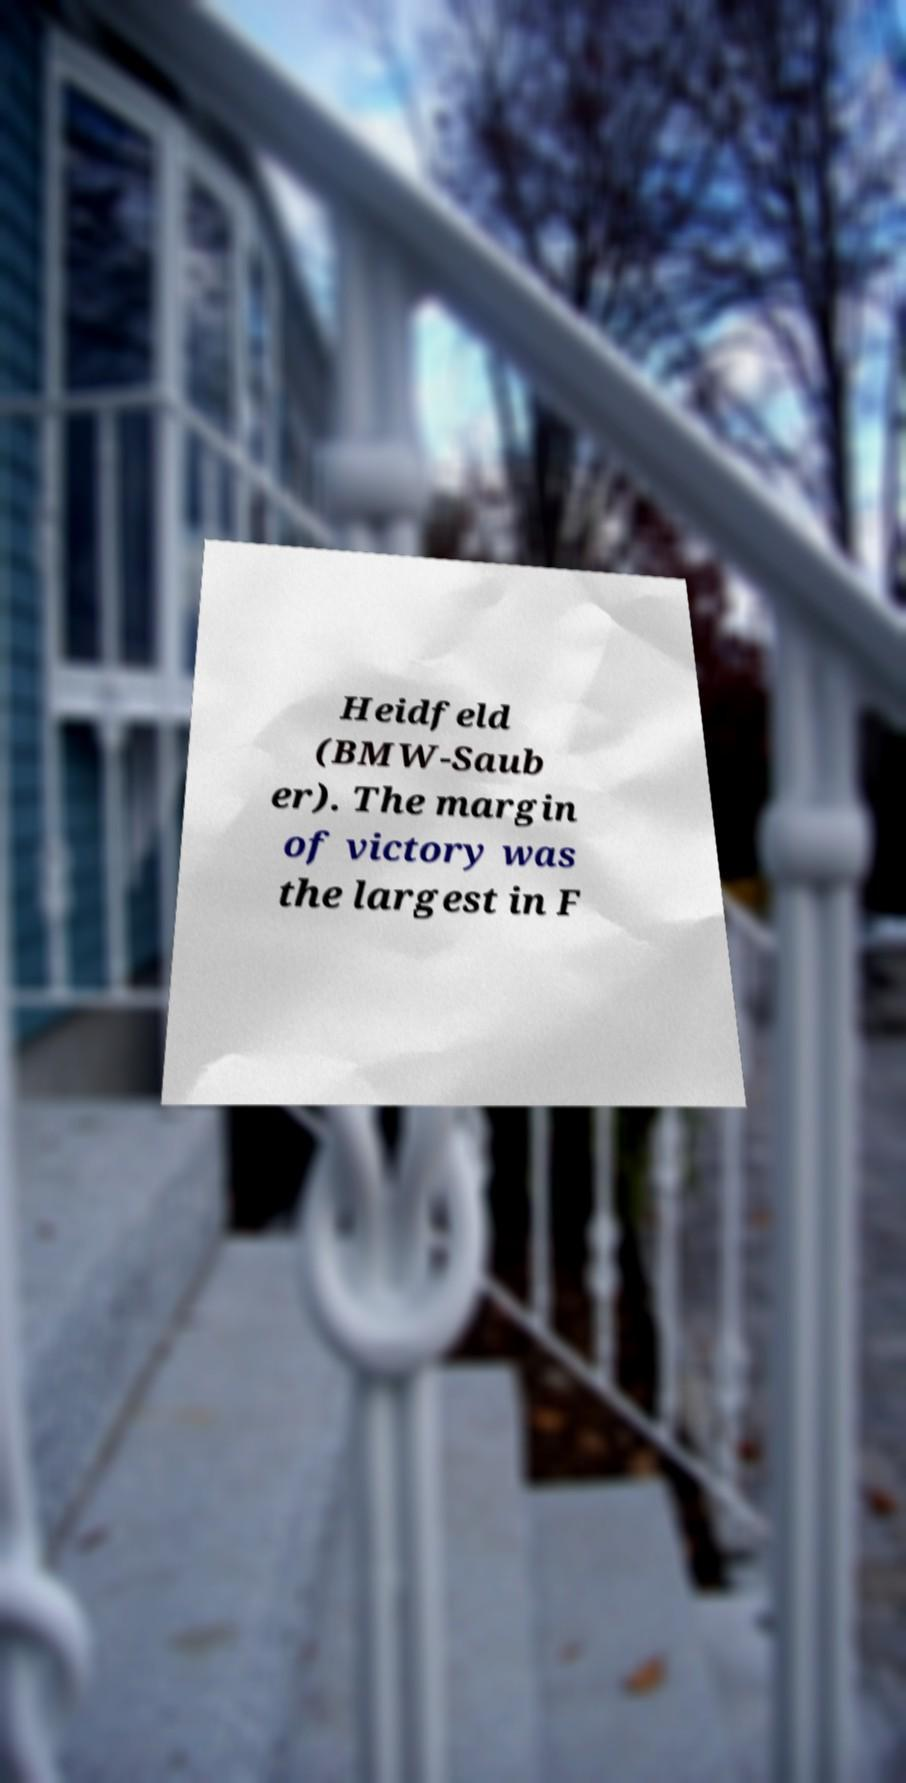Can you read and provide the text displayed in the image?This photo seems to have some interesting text. Can you extract and type it out for me? Heidfeld (BMW-Saub er). The margin of victory was the largest in F 